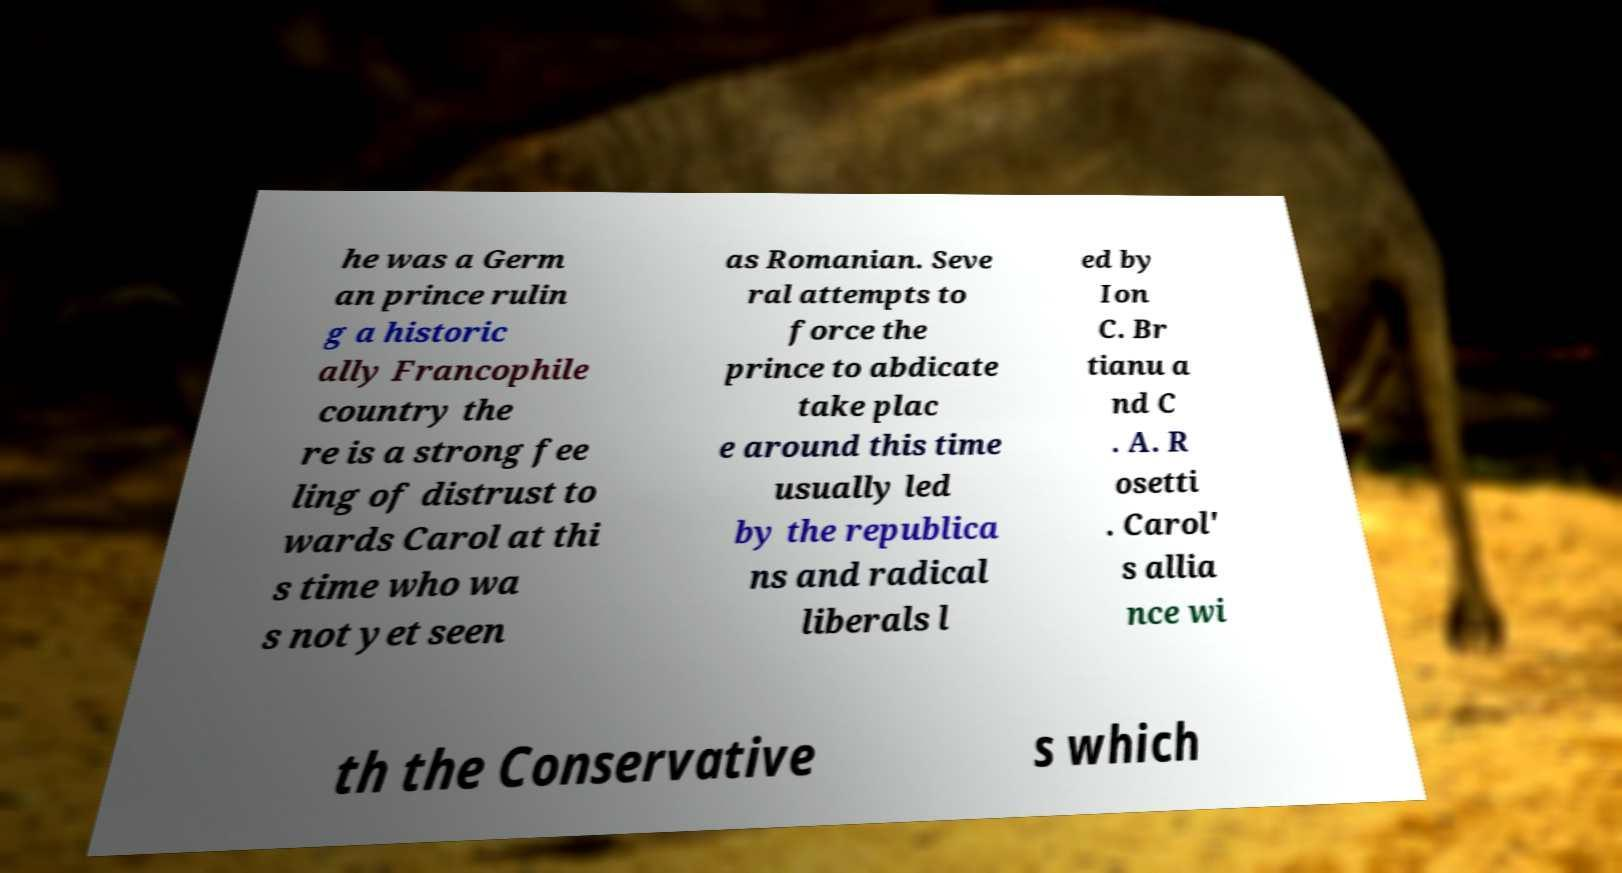Can you accurately transcribe the text from the provided image for me? he was a Germ an prince rulin g a historic ally Francophile country the re is a strong fee ling of distrust to wards Carol at thi s time who wa s not yet seen as Romanian. Seve ral attempts to force the prince to abdicate take plac e around this time usually led by the republica ns and radical liberals l ed by Ion C. Br tianu a nd C . A. R osetti . Carol' s allia nce wi th the Conservative s which 